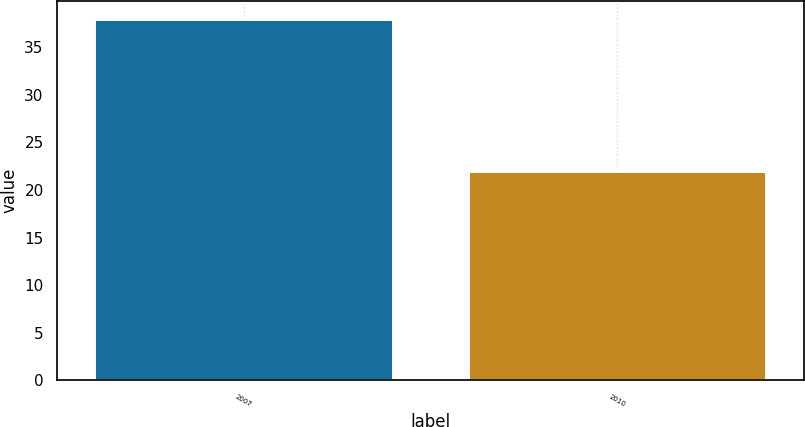<chart> <loc_0><loc_0><loc_500><loc_500><bar_chart><fcel>2007<fcel>2010<nl><fcel>38<fcel>22<nl></chart> 